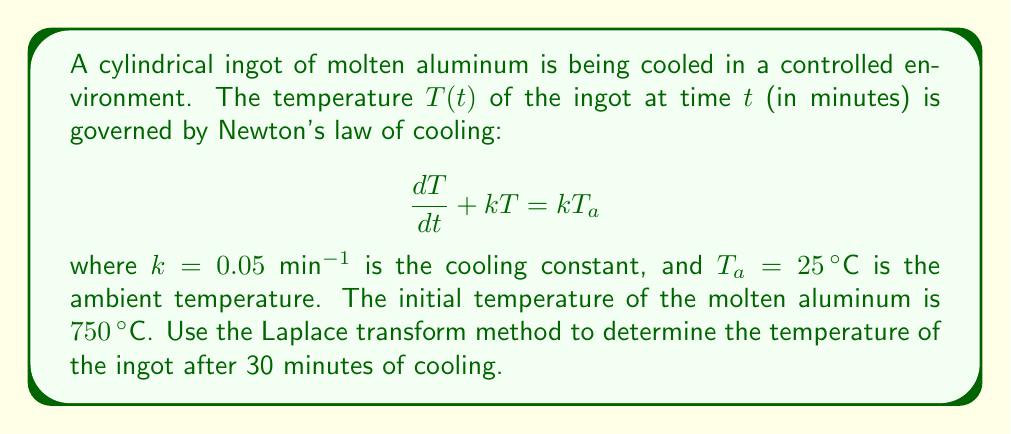Show me your answer to this math problem. To solve this problem using the Laplace transform method, we'll follow these steps:

1) First, let's take the Laplace transform of both sides of the differential equation:

   $\mathcal{L}\{\frac{dT}{dt} + kT\} = \mathcal{L}\{kT_a\}$

2) Using the linearity property and the transform of the derivative:

   $s\mathcal{L}\{T\} - T(0) + k\mathcal{L}\{T\} = k\frac{T_a}{s}$

3) Let $\mathcal{L}\{T\} = F(s)$. Substituting the known values:

   $sF(s) - 750 + 0.05F(s) = 0.05\frac{25}{s}$

4) Simplify:

   $(s + 0.05)F(s) = 750 + \frac{1.25}{s}$

5) Solve for $F(s)$:

   $F(s) = \frac{750}{s + 0.05} + \frac{1.25}{s(s + 0.05)}$

6) This can be rewritten as:

   $F(s) = \frac{750}{s + 0.05} + \frac{25}{s} - \frac{25}{s + 0.05}$

7) Now we can take the inverse Laplace transform:

   $T(t) = 750e^{-0.05t} + 25 - 25e^{-0.05t}$

8) Simplify:

   $T(t) = 725e^{-0.05t} + 25$

9) To find the temperature after 30 minutes, substitute $t = 30$:

   $T(30) = 725e^{-0.05(30)} + 25$

10) Calculate:

    $T(30) = 725(0.2231) + 25 = 186.75°C$
Answer: The temperature of the aluminum ingot after 30 minutes of cooling is approximately $186.75°C$. 